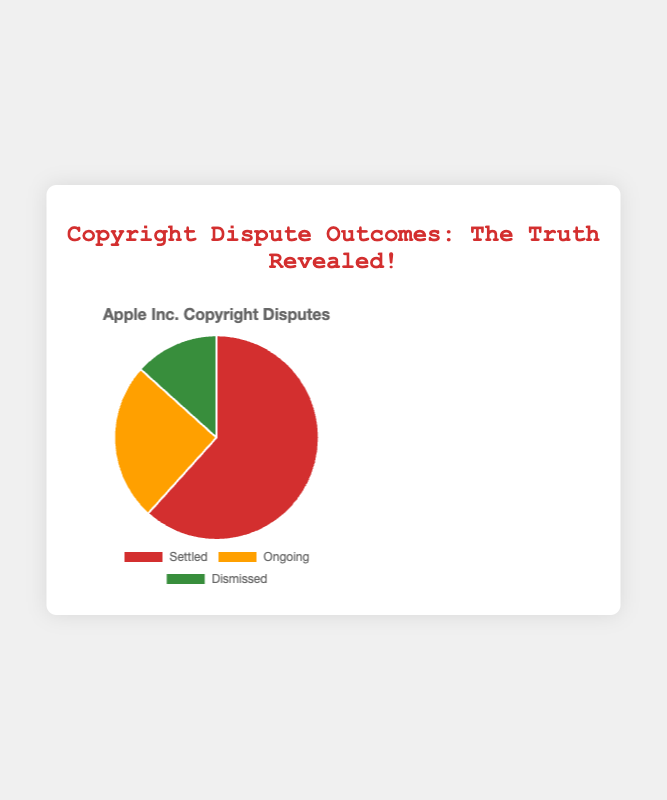Is the number of settled disputes greater than the combined number of ongoing and dismissed disputes? To determine this, we compare the number of settled disputes (37) with the sum of ongoing (15) and dismissed disputes (8). Adding the ongoing and dismissed disputes gives 15 + 8 = 23. Since 37 > 23, the number of settled disputes is greater.
Answer: Yes What proportion of the disputes are ongoing? To find the proportion, divide the number of ongoing disputes by the total number of disputes. Total disputes = 37 (settled) + 15 (ongoing) + 8 (dismissed) = 60. The proportion is 15/60, which simplifies to 25%.
Answer: 25% Which category has the lowest number of disputes? Visually compare the numbers in the pie chart. The dismissed category has the smallest section.
Answer: Dismissed How many more settled disputes are there compared to dismissed disputes? Subtract the number of dismissed disputes (8) from the number of settled disputes (37). 37 - 8 = 29. Hence, there are 29 more settled disputes than dismissed.
Answer: 29 What is the difference between the number of ongoing and dismissed disputes? Subtract the number of dismissed disputes (8) from the number of ongoing disputes (15). 15 - 8 = 7. Thus, the difference is 7.
Answer: 7 If the disputed cases were equally divided among the three categories, how many cases would each category have? Divide the total number of disputes (60) by the three categories. 60 / 3 = 20. Each category would have 20 cases if equally divided.
Answer: 20 What percentage of disputes are either settled or dismissed? Add the number of settled (37) and dismissed disputes (8) to get 45. Calculate the percentage: (45 / 60) * 100 = 75%.
Answer: 75% What color represents the settled disputes in the pie chart? From the visual representation in the pie chart, the settled disputes are represented by the red section.
Answer: Red 